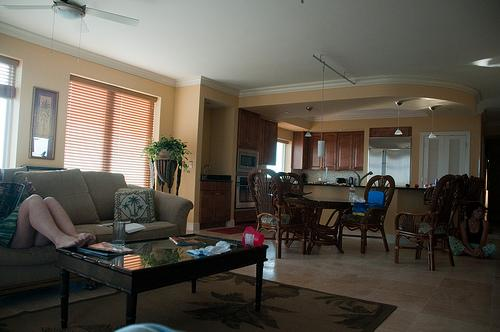What type of blinds are covering the windows in the image? The blinds covering the windows are wooden blinds. Describe the plant near the window and its location. The plant is potted and is positioned next to the window in a plant stand. What type of decoration is present on the throw pillow on the couch? The throw pillow has a palm tree design on it. Do the image details provide any information about the state of lights in the room? If yes, describe it. Yes, the image details suggest that the lights are off in the room. What is the position of the person sitting on the couch and what they are doing with their feet? The person is sitting on the couch with their feet up on the coffee table. What type of light fixtures are hanging from the kitchen's ceiling and their quantity? There are three drop lights hanging from the kitchen ceiling. What is the significant object on the wooden dining room table and its type? There is a water bottle on the wooden dining room table, which is made of plastic. Identify the type of room in the image and the most noticeable objects. The image is of a living room with a sofa, coffee table, area rug, and wooden chairs around a table. What is the color and type of the baby seat in the wicker chair? The baby seat is blue and is a high chair. Can you count how many chairs are around the table? There are four chairs around the table. Interpret the actions of the person who is sitting down. The person is sitting on the couch and has bent legs with their feet on the table. Where is the person sitting and what action are they performing? The person is sitting on the couch with their feet up on the table. Explain the seating arrangement at the table. There are wooden chairs around the table, including one with a blue child's high chair, and three other regular chairs. What is on the wooden dining room table? There is a bottle of water and a red object on the wooden dining room table. What is the color and type of light fixture hanging from the ceiling? The light fixture is white and made of stainless steel. Express the relationship between the wooden and glass coffee table and the living room area rug. The wooden and glass coffee table is placed on top of the living room area rug. Describe the ceiling fan in the room. The ceiling fan has white blades. Are there any objects on the wooden dining room table? Yes, there is a water bottle and a red object on the table. Characterize the window treatment in the room. The window has wooden blinds covering them, which are closed. Identify the location and style of the coffee table in front of the couch. The coffee table is in front of the couch and has magazines on it. Which one of the following items has a palm tree design: couch throw pillow, water bottle, or coffee table? couch throw pillow How many lights are hanging from the kitchen ceiling? three drop lights Is there a baby seat in the room? If so, what is its color and where is it located? Yes, there is a blue baby seat in the brown wooden chair. What type of style does the throw pillow on the couch have? The throw pillow has a palm trees design. Is there a chair around the table for a child? If so, describe it. Yes, there is a blue child's high chair in a wicker chair. Discuss the nature of the cabinets in the room. The cabinets are brown and made of wood. Describe the location and appearance of the potted plant in the room. The potted plant is by the window and placed in a plant stand. What is the primary piece of furniture in the living room? a living room sofa Locate the refrigerator and describe its appearance. The refrigerator is stainless steel and has a door with two panels. 